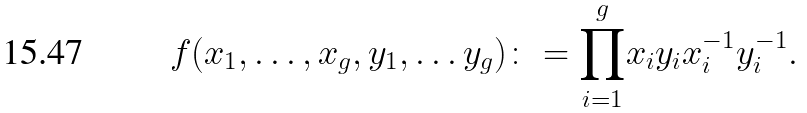Convert formula to latex. <formula><loc_0><loc_0><loc_500><loc_500>f ( x _ { 1 } , \dots , x _ { g } , y _ { 1 } , \dots y _ { g } ) \colon = { \prod _ { i = 1 } ^ { g } } x _ { i } y _ { i } x _ { i } ^ { - 1 } y _ { i } ^ { - 1 } .</formula> 